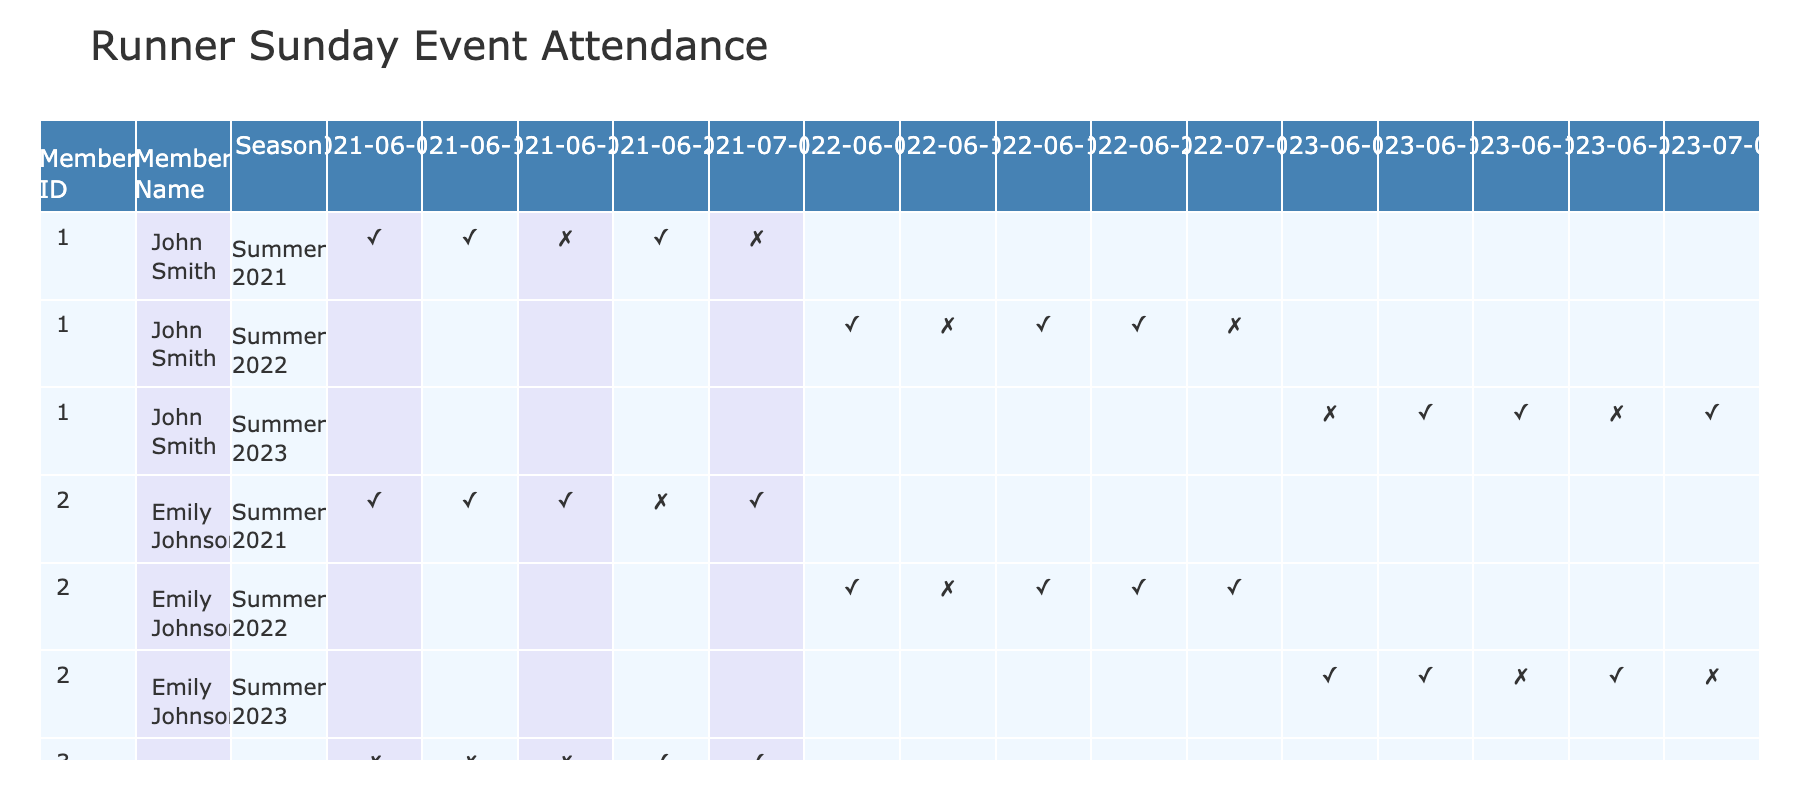What was John Smith's attendance on June 20, 2021? John Smith attended the event on June 20, 2021, as shown by the checkmark (✓) in that cell of the table.
Answer: ✓ What is the average attendance of Emily Johnson in Summer 2022? In Summer 2022, Emily Johnson attended 4 events out of 5. Thus, her average attendance is 4/5 = 0.8 or 80%.
Answer: 80% Did David Lee attend the event on June 12, 2023? Looking at the row for David Lee on June 12, 2023, there is a cross (✗) indicating that he did not attend that event.
Answer: No How many events did John Smith attend in Summer 2021? John Smith attended 3 out of 5 events in Summer 2021, as seen in the respective rows of the table. The events he attended occurred on June 6, June 13, and June 27.
Answer: 3 What was the total number of events attended by Emily Johnson over all seasons? Emily Johnson attended a total of 10 events across the three seasons. Summer 2021: 4, Summer 2022: 4, Summer 2023: 2. Thus, the total is 4 + 4 + 2 = 10.
Answer: 10 In which season did David Lee have the highest attendance? David Lee had his highest attendance in Summer 2023, where he attended 3 out of 5 events. In Summer 2021, he attended 2 and in Summer 2022, he attended 2 as well.
Answer: Summer 2023 What percentage of events did Emily Johnson miss in Summer 2023? Emily Johnson attended 3 out of 5 events in Summer 2023. Thus, she missed 2 events, which is 2/5 = 0.4 or 40%.
Answer: 40% Was there any event in Summer 2022 when John Smith did not attend? Yes, on June 12, 2022, John Smith did not attend the event as indicated by the cross (✗) in the table.
Answer: Yes How many events did David Lee attend in total from Summer 2021 to Summer 2023? David Lee attended 3 events in Summer 2021, 2 events in Summer 2022, and 3 events in Summer 2023, totaling 3 + 2 + 3 = 8 events.
Answer: 8 